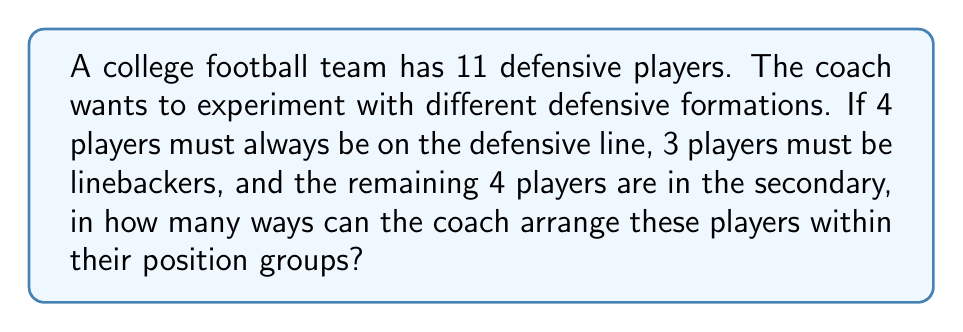Solve this math problem. Let's break this down step-by-step:

1) We have three distinct groups of players:
   - 4 players on the defensive line
   - 3 linebackers
   - 4 players in the secondary

2) For each group, we need to calculate the number of ways to arrange the players:
   
   a) For the defensive line: 
      There are 4! ways to arrange 4 players.
   
   b) For the linebackers:
      There are 3! ways to arrange 3 players.
   
   c) For the secondary:
      There are 4! ways to arrange 4 players.

3) By the multiplication principle, the total number of ways to arrange all players is the product of these individual arrangements:

   $$ \text{Total arrangements} = 4! \times 3! \times 4! $$

4) Let's calculate this:
   $$ 4! \times 3! \times 4! = 24 \times 6 \times 24 = 3,456 $$

Therefore, the coach can arrange the players within their position groups in 3,456 different ways.
Answer: 3,456 